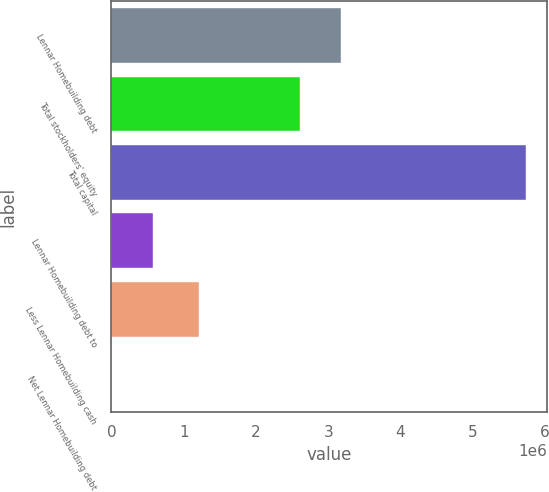<chart> <loc_0><loc_0><loc_500><loc_500><bar_chart><fcel>Lennar Homebuilding debt<fcel>Total stockholders' equity<fcel>Total capital<fcel>Lennar Homebuilding debt to<fcel>Less Lennar Homebuilding cash<fcel>Net Lennar Homebuilding debt<nl><fcel>3.18266e+06<fcel>2.60895e+06<fcel>5.7371e+06<fcel>573748<fcel>1.20725e+06<fcel>42.4<nl></chart> 